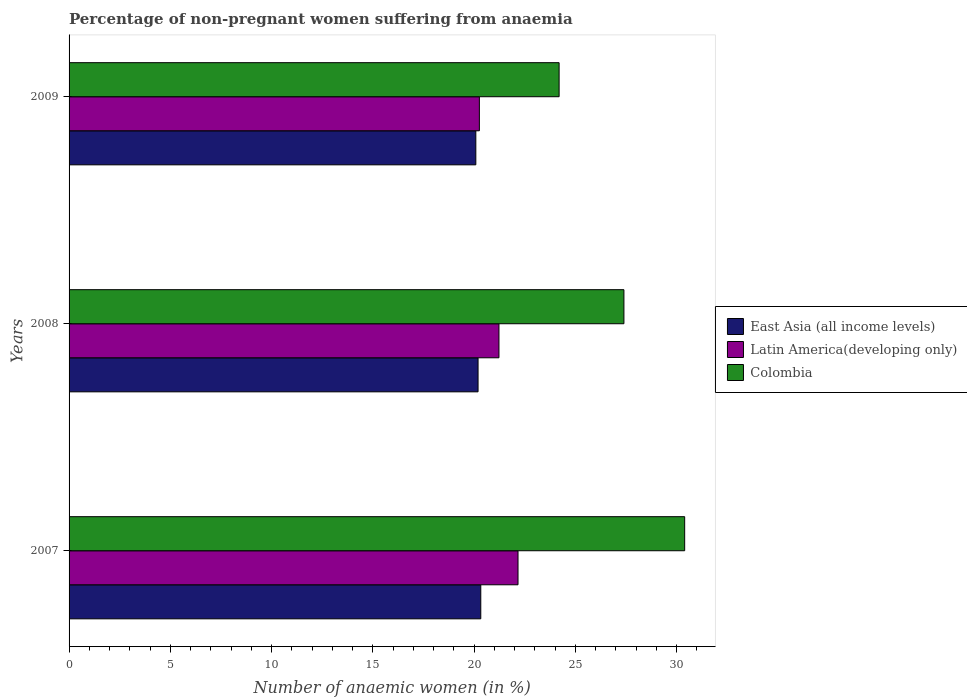How many different coloured bars are there?
Your answer should be very brief. 3. Are the number of bars per tick equal to the number of legend labels?
Make the answer very short. Yes. How many bars are there on the 1st tick from the bottom?
Provide a succinct answer. 3. What is the label of the 3rd group of bars from the top?
Your answer should be very brief. 2007. In how many cases, is the number of bars for a given year not equal to the number of legend labels?
Your answer should be very brief. 0. What is the percentage of non-pregnant women suffering from anaemia in Latin America(developing only) in 2008?
Keep it short and to the point. 21.23. Across all years, what is the maximum percentage of non-pregnant women suffering from anaemia in Colombia?
Your answer should be compact. 30.4. Across all years, what is the minimum percentage of non-pregnant women suffering from anaemia in East Asia (all income levels)?
Your answer should be very brief. 20.09. In which year was the percentage of non-pregnant women suffering from anaemia in Colombia minimum?
Offer a very short reply. 2009. What is the total percentage of non-pregnant women suffering from anaemia in Latin America(developing only) in the graph?
Provide a succinct answer. 63.66. What is the difference between the percentage of non-pregnant women suffering from anaemia in East Asia (all income levels) in 2007 and that in 2008?
Offer a terse response. 0.13. What is the difference between the percentage of non-pregnant women suffering from anaemia in Latin America(developing only) in 2009 and the percentage of non-pregnant women suffering from anaemia in East Asia (all income levels) in 2007?
Keep it short and to the point. -0.07. What is the average percentage of non-pregnant women suffering from anaemia in East Asia (all income levels) per year?
Keep it short and to the point. 20.21. In the year 2009, what is the difference between the percentage of non-pregnant women suffering from anaemia in East Asia (all income levels) and percentage of non-pregnant women suffering from anaemia in Latin America(developing only)?
Make the answer very short. -0.17. In how many years, is the percentage of non-pregnant women suffering from anaemia in East Asia (all income levels) greater than 14 %?
Make the answer very short. 3. What is the ratio of the percentage of non-pregnant women suffering from anaemia in Colombia in 2008 to that in 2009?
Make the answer very short. 1.13. Is the percentage of non-pregnant women suffering from anaemia in East Asia (all income levels) in 2008 less than that in 2009?
Your answer should be very brief. No. Is the difference between the percentage of non-pregnant women suffering from anaemia in East Asia (all income levels) in 2007 and 2009 greater than the difference between the percentage of non-pregnant women suffering from anaemia in Latin America(developing only) in 2007 and 2009?
Ensure brevity in your answer.  No. What is the difference between the highest and the lowest percentage of non-pregnant women suffering from anaemia in Colombia?
Ensure brevity in your answer.  6.2. What does the 1st bar from the bottom in 2007 represents?
Offer a terse response. East Asia (all income levels). Is it the case that in every year, the sum of the percentage of non-pregnant women suffering from anaemia in Colombia and percentage of non-pregnant women suffering from anaemia in Latin America(developing only) is greater than the percentage of non-pregnant women suffering from anaemia in East Asia (all income levels)?
Provide a short and direct response. Yes. How many years are there in the graph?
Offer a terse response. 3. Does the graph contain any zero values?
Provide a short and direct response. No. Where does the legend appear in the graph?
Provide a short and direct response. Center right. How many legend labels are there?
Keep it short and to the point. 3. How are the legend labels stacked?
Provide a short and direct response. Vertical. What is the title of the graph?
Your response must be concise. Percentage of non-pregnant women suffering from anaemia. What is the label or title of the X-axis?
Your answer should be compact. Number of anaemic women (in %). What is the label or title of the Y-axis?
Offer a terse response. Years. What is the Number of anaemic women (in %) in East Asia (all income levels) in 2007?
Ensure brevity in your answer.  20.33. What is the Number of anaemic women (in %) in Latin America(developing only) in 2007?
Offer a very short reply. 22.17. What is the Number of anaemic women (in %) of Colombia in 2007?
Make the answer very short. 30.4. What is the Number of anaemic women (in %) of East Asia (all income levels) in 2008?
Ensure brevity in your answer.  20.2. What is the Number of anaemic women (in %) of Latin America(developing only) in 2008?
Your answer should be very brief. 21.23. What is the Number of anaemic women (in %) in Colombia in 2008?
Offer a very short reply. 27.4. What is the Number of anaemic women (in %) of East Asia (all income levels) in 2009?
Offer a very short reply. 20.09. What is the Number of anaemic women (in %) in Latin America(developing only) in 2009?
Offer a terse response. 20.26. What is the Number of anaemic women (in %) in Colombia in 2009?
Your answer should be very brief. 24.2. Across all years, what is the maximum Number of anaemic women (in %) of East Asia (all income levels)?
Your answer should be very brief. 20.33. Across all years, what is the maximum Number of anaemic women (in %) of Latin America(developing only)?
Offer a terse response. 22.17. Across all years, what is the maximum Number of anaemic women (in %) of Colombia?
Offer a terse response. 30.4. Across all years, what is the minimum Number of anaemic women (in %) in East Asia (all income levels)?
Offer a very short reply. 20.09. Across all years, what is the minimum Number of anaemic women (in %) in Latin America(developing only)?
Keep it short and to the point. 20.26. Across all years, what is the minimum Number of anaemic women (in %) of Colombia?
Your answer should be very brief. 24.2. What is the total Number of anaemic women (in %) of East Asia (all income levels) in the graph?
Your response must be concise. 60.62. What is the total Number of anaemic women (in %) of Latin America(developing only) in the graph?
Give a very brief answer. 63.66. What is the difference between the Number of anaemic women (in %) in East Asia (all income levels) in 2007 and that in 2008?
Make the answer very short. 0.13. What is the difference between the Number of anaemic women (in %) of Latin America(developing only) in 2007 and that in 2008?
Your answer should be very brief. 0.94. What is the difference between the Number of anaemic women (in %) in East Asia (all income levels) in 2007 and that in 2009?
Ensure brevity in your answer.  0.24. What is the difference between the Number of anaemic women (in %) of Latin America(developing only) in 2007 and that in 2009?
Offer a very short reply. 1.91. What is the difference between the Number of anaemic women (in %) of East Asia (all income levels) in 2008 and that in 2009?
Offer a terse response. 0.11. What is the difference between the Number of anaemic women (in %) in Latin America(developing only) in 2008 and that in 2009?
Make the answer very short. 0.97. What is the difference between the Number of anaemic women (in %) in Colombia in 2008 and that in 2009?
Provide a short and direct response. 3.2. What is the difference between the Number of anaemic women (in %) in East Asia (all income levels) in 2007 and the Number of anaemic women (in %) in Latin America(developing only) in 2008?
Keep it short and to the point. -0.9. What is the difference between the Number of anaemic women (in %) of East Asia (all income levels) in 2007 and the Number of anaemic women (in %) of Colombia in 2008?
Provide a succinct answer. -7.07. What is the difference between the Number of anaemic women (in %) in Latin America(developing only) in 2007 and the Number of anaemic women (in %) in Colombia in 2008?
Your answer should be compact. -5.23. What is the difference between the Number of anaemic women (in %) of East Asia (all income levels) in 2007 and the Number of anaemic women (in %) of Latin America(developing only) in 2009?
Provide a succinct answer. 0.07. What is the difference between the Number of anaemic women (in %) of East Asia (all income levels) in 2007 and the Number of anaemic women (in %) of Colombia in 2009?
Offer a very short reply. -3.87. What is the difference between the Number of anaemic women (in %) of Latin America(developing only) in 2007 and the Number of anaemic women (in %) of Colombia in 2009?
Keep it short and to the point. -2.03. What is the difference between the Number of anaemic women (in %) of East Asia (all income levels) in 2008 and the Number of anaemic women (in %) of Latin America(developing only) in 2009?
Provide a short and direct response. -0.06. What is the difference between the Number of anaemic women (in %) of East Asia (all income levels) in 2008 and the Number of anaemic women (in %) of Colombia in 2009?
Your answer should be very brief. -4. What is the difference between the Number of anaemic women (in %) in Latin America(developing only) in 2008 and the Number of anaemic women (in %) in Colombia in 2009?
Your answer should be compact. -2.97. What is the average Number of anaemic women (in %) of East Asia (all income levels) per year?
Give a very brief answer. 20.21. What is the average Number of anaemic women (in %) in Latin America(developing only) per year?
Keep it short and to the point. 21.22. What is the average Number of anaemic women (in %) of Colombia per year?
Your response must be concise. 27.33. In the year 2007, what is the difference between the Number of anaemic women (in %) of East Asia (all income levels) and Number of anaemic women (in %) of Latin America(developing only)?
Keep it short and to the point. -1.84. In the year 2007, what is the difference between the Number of anaemic women (in %) of East Asia (all income levels) and Number of anaemic women (in %) of Colombia?
Ensure brevity in your answer.  -10.07. In the year 2007, what is the difference between the Number of anaemic women (in %) of Latin America(developing only) and Number of anaemic women (in %) of Colombia?
Offer a very short reply. -8.23. In the year 2008, what is the difference between the Number of anaemic women (in %) of East Asia (all income levels) and Number of anaemic women (in %) of Latin America(developing only)?
Offer a very short reply. -1.03. In the year 2008, what is the difference between the Number of anaemic women (in %) in East Asia (all income levels) and Number of anaemic women (in %) in Colombia?
Your answer should be very brief. -7.2. In the year 2008, what is the difference between the Number of anaemic women (in %) of Latin America(developing only) and Number of anaemic women (in %) of Colombia?
Offer a very short reply. -6.17. In the year 2009, what is the difference between the Number of anaemic women (in %) in East Asia (all income levels) and Number of anaemic women (in %) in Latin America(developing only)?
Offer a very short reply. -0.17. In the year 2009, what is the difference between the Number of anaemic women (in %) in East Asia (all income levels) and Number of anaemic women (in %) in Colombia?
Provide a succinct answer. -4.11. In the year 2009, what is the difference between the Number of anaemic women (in %) of Latin America(developing only) and Number of anaemic women (in %) of Colombia?
Your answer should be very brief. -3.94. What is the ratio of the Number of anaemic women (in %) of Latin America(developing only) in 2007 to that in 2008?
Give a very brief answer. 1.04. What is the ratio of the Number of anaemic women (in %) in Colombia in 2007 to that in 2008?
Your response must be concise. 1.11. What is the ratio of the Number of anaemic women (in %) in East Asia (all income levels) in 2007 to that in 2009?
Give a very brief answer. 1.01. What is the ratio of the Number of anaemic women (in %) in Latin America(developing only) in 2007 to that in 2009?
Offer a terse response. 1.09. What is the ratio of the Number of anaemic women (in %) of Colombia in 2007 to that in 2009?
Your answer should be very brief. 1.26. What is the ratio of the Number of anaemic women (in %) in East Asia (all income levels) in 2008 to that in 2009?
Keep it short and to the point. 1.01. What is the ratio of the Number of anaemic women (in %) of Latin America(developing only) in 2008 to that in 2009?
Ensure brevity in your answer.  1.05. What is the ratio of the Number of anaemic women (in %) of Colombia in 2008 to that in 2009?
Offer a terse response. 1.13. What is the difference between the highest and the second highest Number of anaemic women (in %) in East Asia (all income levels)?
Your answer should be very brief. 0.13. What is the difference between the highest and the second highest Number of anaemic women (in %) in Latin America(developing only)?
Offer a very short reply. 0.94. What is the difference between the highest and the lowest Number of anaemic women (in %) of East Asia (all income levels)?
Your response must be concise. 0.24. What is the difference between the highest and the lowest Number of anaemic women (in %) of Latin America(developing only)?
Provide a short and direct response. 1.91. What is the difference between the highest and the lowest Number of anaemic women (in %) of Colombia?
Offer a very short reply. 6.2. 